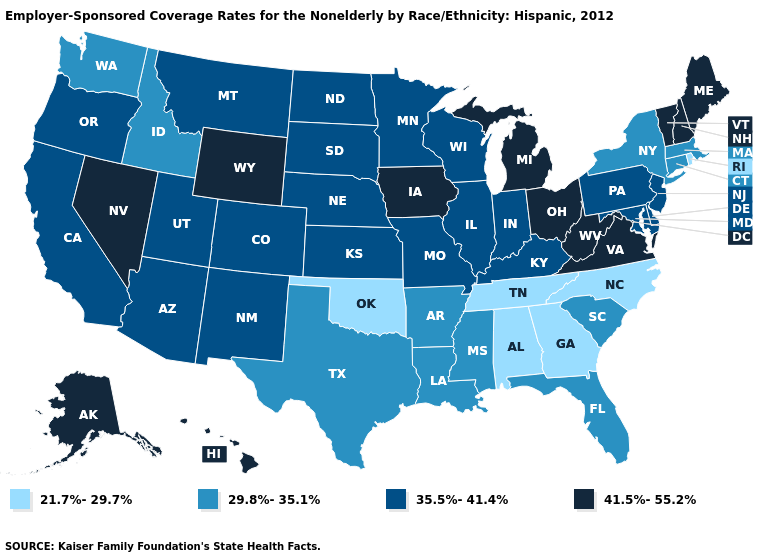What is the value of Delaware?
Concise answer only. 35.5%-41.4%. What is the highest value in states that border New Jersey?
Answer briefly. 35.5%-41.4%. What is the value of Tennessee?
Quick response, please. 21.7%-29.7%. Name the states that have a value in the range 21.7%-29.7%?
Answer briefly. Alabama, Georgia, North Carolina, Oklahoma, Rhode Island, Tennessee. Does Oklahoma have a lower value than Georgia?
Concise answer only. No. Which states have the lowest value in the MidWest?
Give a very brief answer. Illinois, Indiana, Kansas, Minnesota, Missouri, Nebraska, North Dakota, South Dakota, Wisconsin. Name the states that have a value in the range 29.8%-35.1%?
Quick response, please. Arkansas, Connecticut, Florida, Idaho, Louisiana, Massachusetts, Mississippi, New York, South Carolina, Texas, Washington. Does Michigan have a higher value than Virginia?
Give a very brief answer. No. What is the value of Delaware?
Keep it brief. 35.5%-41.4%. Which states have the lowest value in the USA?
Concise answer only. Alabama, Georgia, North Carolina, Oklahoma, Rhode Island, Tennessee. Name the states that have a value in the range 21.7%-29.7%?
Answer briefly. Alabama, Georgia, North Carolina, Oklahoma, Rhode Island, Tennessee. What is the lowest value in the South?
Concise answer only. 21.7%-29.7%. Among the states that border Illinois , does Kentucky have the highest value?
Write a very short answer. No. Among the states that border Delaware , which have the lowest value?
Answer briefly. Maryland, New Jersey, Pennsylvania. 